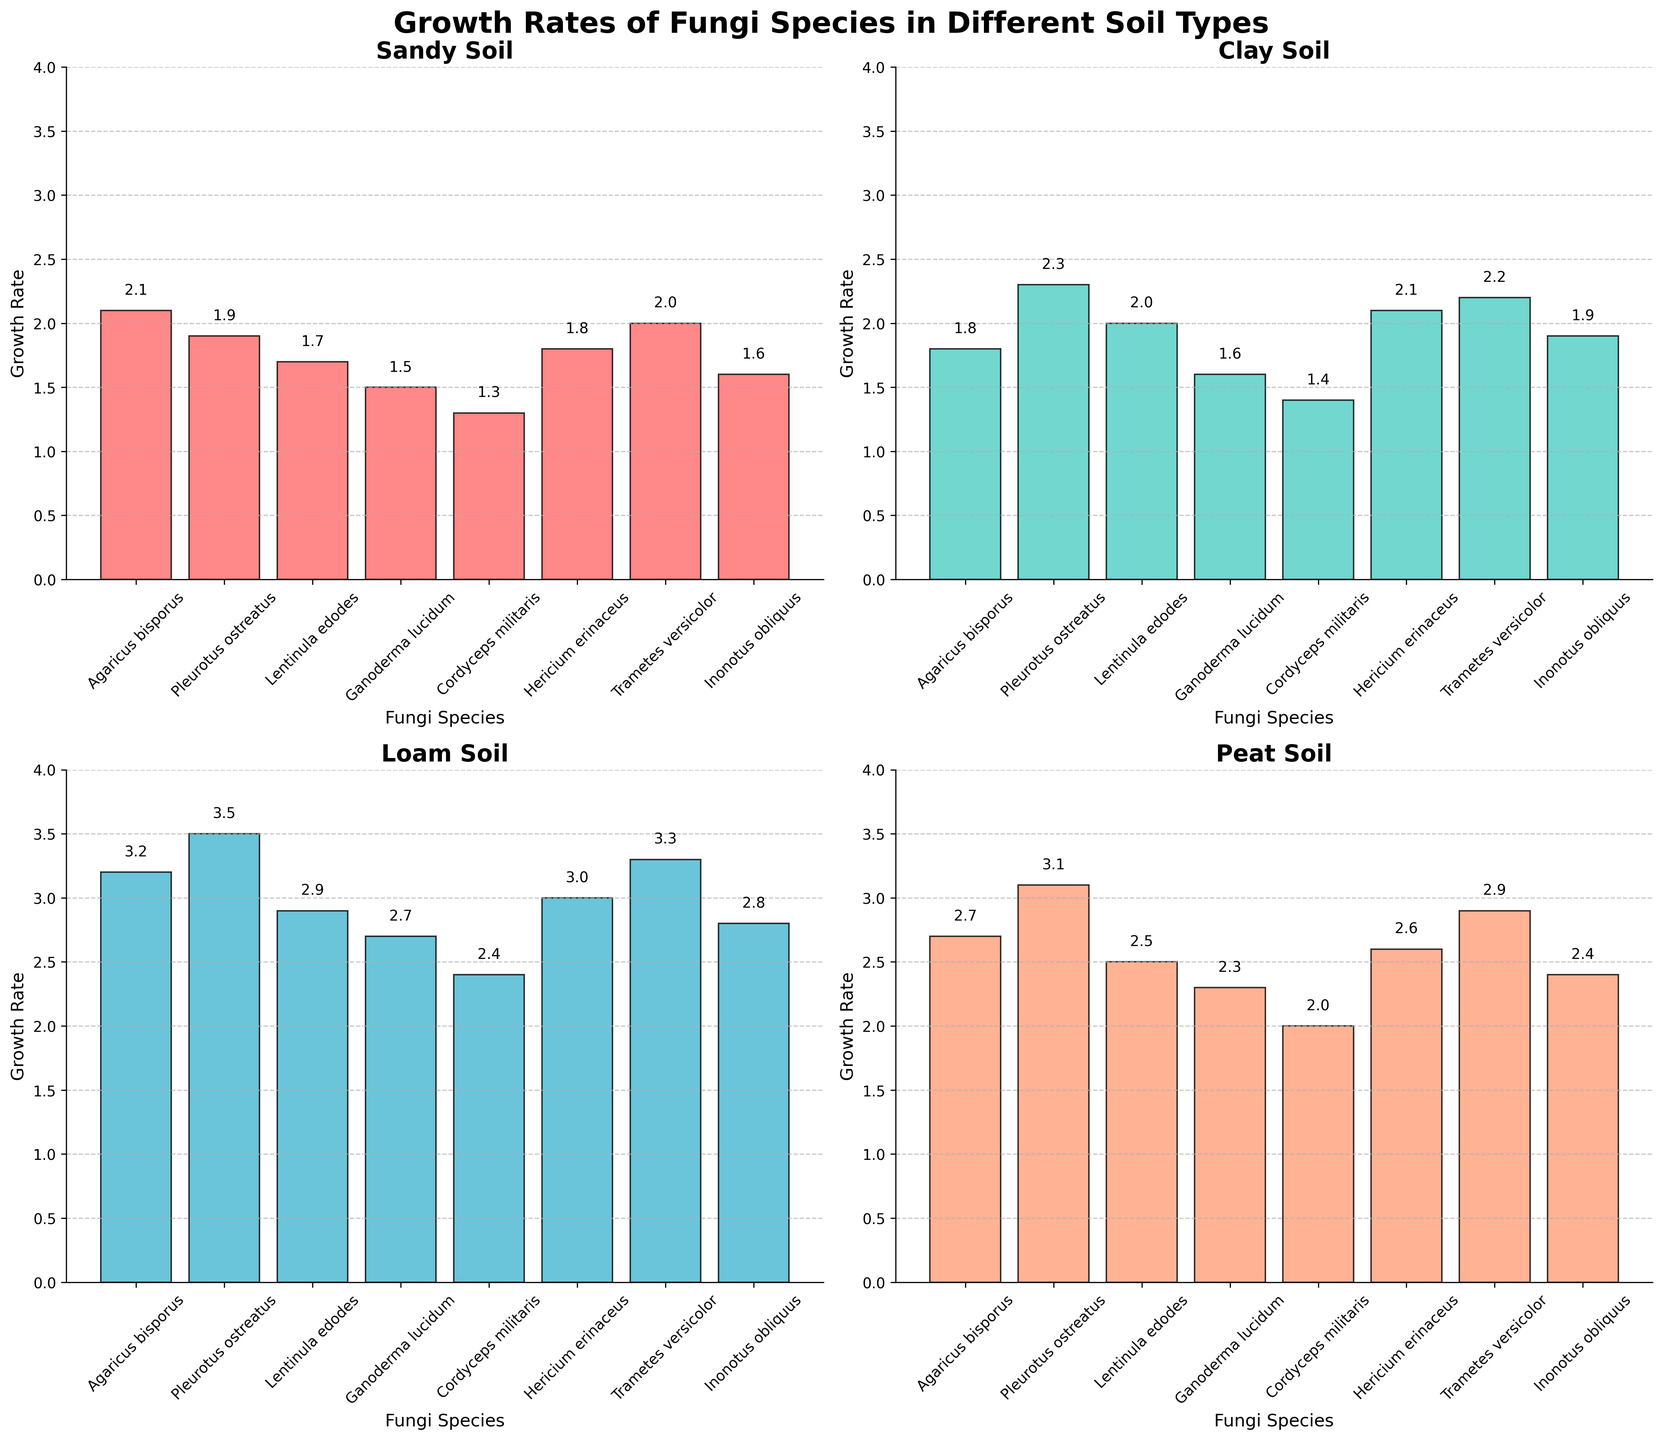What is the title of the figure? The title is found at the top of the figure in a larger and bold font, typically summarizing the content of the entire figure.
Answer: Growth Rates of Fungi Species in Different Soil Types What soil type shows the highest growth rate for Lentinula edodes? Look for the 'Lentinula edodes' bars across all subplots and identify the tallest bar.
Answer: Loam Soil How does the growth rate of Pleurotus ostreatus in Sandy Soil compare to that in Clay Soil? Check the heights of the bars for 'Pleurotus ostreatus' in both the Sandy Soil and Clay Soil subplots. Compare their heights.
Answer: Clay Soil is higher Which fungi species has the lowest growth rate in Peat Soil? Look at the Peat Soil subplot and compare the heights of all the bars. The shortest bar indicates the lowest growth rate.
Answer: Cordyceps militaris What is the difference in growth rates of Ganoderma lucidum between Loam Soil and Sandy Soil? Identify the heights of the bars for 'Ganoderma lucidum' in Loam Soil and Sandy Soil subplots. Subtract the growth rate in Sandy Soil from that in Loam Soil.
Answer: 1.2 Is the growth rate of Inonotus obliquus in Clay Soil greater than 2? Check the height of the 'Inonotus obliquus' bar in the Clay Soil subplot and see if it's above the 2 mark on the y-axis.
Answer: No What is the average growth rate of Trametes versicolor across all soil types? Add the growth rates of 'Trametes versicolor' from all four subplots and divide by the number of soil types (4).
Answer: 2.6 Which soil type shows the most similar growth rates across different fungi species? Compare the range of growth rates (difference between highest and lowest) of all fungi species for each soil type. The soil type with the smallest range is the most uniform.
Answer: Clay Soil Between Agaricus bisporus and Hericium erinaceus, which species has a higher growth rate in Loam Soil? Compare the heights of the bars for 'Agaricus bisporus' and 'Hericium erinaceus' in the Loam Soil subplot.
Answer: Agaricus bisporus Which fungi species has the highest average growth rate across the soil types? Calculate the average growth rate for each species by summing its growth rates in all soil types and dividing by 4. Compare these averages to determine the highest.
Answer: Pleurotus ostreatus 